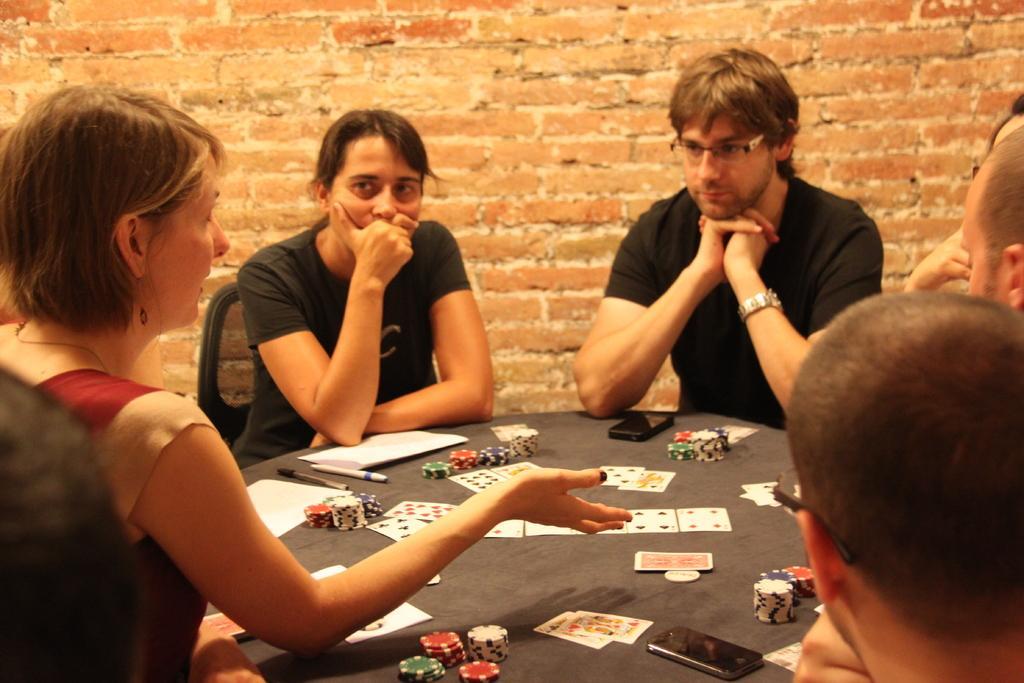Can you describe this image briefly? A group of people are sitting around a table playing poker. Of them two are women ,three are men. A woman is explaining to the remaining people. 